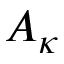<formula> <loc_0><loc_0><loc_500><loc_500>A _ { \kappa }</formula> 